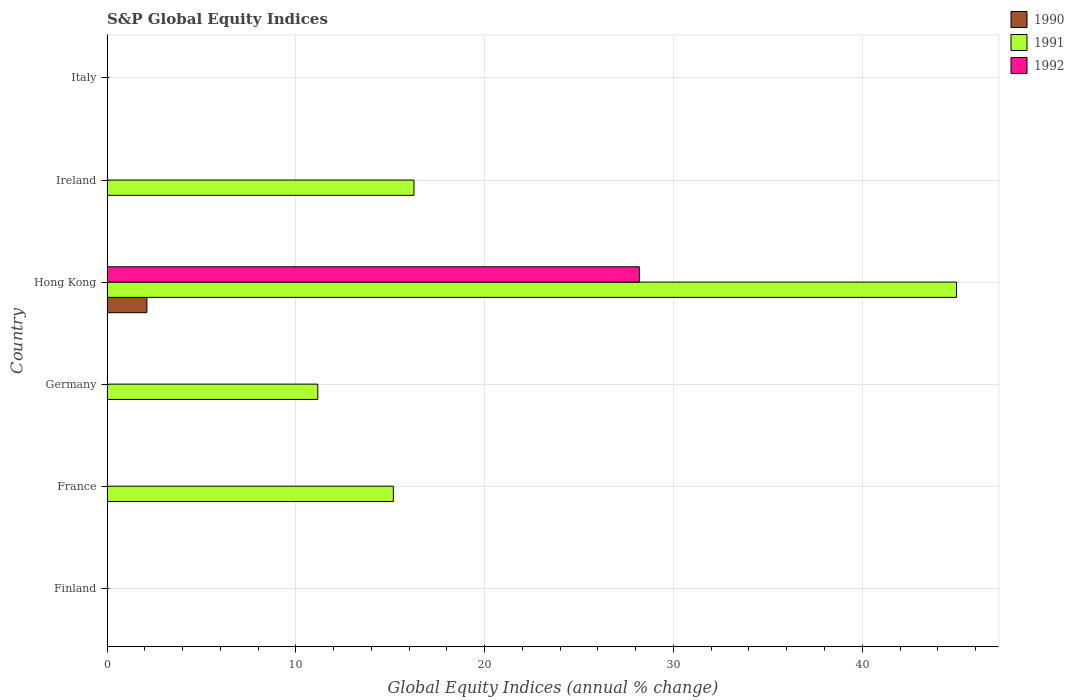Are the number of bars on each tick of the Y-axis equal?
Provide a succinct answer. No. In how many cases, is the number of bars for a given country not equal to the number of legend labels?
Make the answer very short. 5. What is the global equity indices in 1991 in Finland?
Keep it short and to the point. 0. Across all countries, what is the maximum global equity indices in 1990?
Your response must be concise. 2.11. In which country was the global equity indices in 1990 maximum?
Provide a succinct answer. Hong Kong. What is the total global equity indices in 1991 in the graph?
Make the answer very short. 87.58. What is the difference between the global equity indices in 1991 in France and that in Hong Kong?
Your answer should be compact. -29.83. What is the difference between the global equity indices in 1992 in Hong Kong and the global equity indices in 1991 in Germany?
Give a very brief answer. 17.03. What is the average global equity indices in 1990 per country?
Make the answer very short. 0.35. What is the difference between the global equity indices in 1992 and global equity indices in 1990 in Hong Kong?
Keep it short and to the point. 26.08. What is the difference between the highest and the second highest global equity indices in 1991?
Provide a short and direct response. 28.74. What is the difference between the highest and the lowest global equity indices in 1990?
Offer a very short reply. 2.11. In how many countries, is the global equity indices in 1991 greater than the average global equity indices in 1991 taken over all countries?
Offer a terse response. 3. Are all the bars in the graph horizontal?
Offer a terse response. Yes. How many countries are there in the graph?
Your answer should be very brief. 6. What is the difference between two consecutive major ticks on the X-axis?
Offer a very short reply. 10. Where does the legend appear in the graph?
Make the answer very short. Top right. How many legend labels are there?
Provide a succinct answer. 3. How are the legend labels stacked?
Your response must be concise. Vertical. What is the title of the graph?
Provide a short and direct response. S&P Global Equity Indices. What is the label or title of the X-axis?
Make the answer very short. Global Equity Indices (annual % change). What is the Global Equity Indices (annual % change) of 1992 in Finland?
Offer a very short reply. 0. What is the Global Equity Indices (annual % change) in 1990 in France?
Your answer should be very brief. 0. What is the Global Equity Indices (annual % change) of 1991 in France?
Give a very brief answer. 15.17. What is the Global Equity Indices (annual % change) of 1992 in France?
Your answer should be compact. 0. What is the Global Equity Indices (annual % change) in 1990 in Germany?
Your answer should be very brief. 0. What is the Global Equity Indices (annual % change) of 1991 in Germany?
Provide a short and direct response. 11.16. What is the Global Equity Indices (annual % change) of 1992 in Germany?
Offer a terse response. 0. What is the Global Equity Indices (annual % change) of 1990 in Hong Kong?
Your answer should be compact. 2.11. What is the Global Equity Indices (annual % change) of 1991 in Hong Kong?
Your answer should be compact. 44.99. What is the Global Equity Indices (annual % change) of 1992 in Hong Kong?
Your answer should be very brief. 28.19. What is the Global Equity Indices (annual % change) of 1990 in Ireland?
Ensure brevity in your answer.  0. What is the Global Equity Indices (annual % change) in 1991 in Ireland?
Your answer should be compact. 16.26. What is the Global Equity Indices (annual % change) in 1992 in Ireland?
Your answer should be compact. 0. What is the Global Equity Indices (annual % change) in 1991 in Italy?
Offer a very short reply. 0. What is the Global Equity Indices (annual % change) in 1992 in Italy?
Ensure brevity in your answer.  0. Across all countries, what is the maximum Global Equity Indices (annual % change) in 1990?
Give a very brief answer. 2.11. Across all countries, what is the maximum Global Equity Indices (annual % change) in 1991?
Provide a succinct answer. 44.99. Across all countries, what is the maximum Global Equity Indices (annual % change) in 1992?
Provide a succinct answer. 28.19. Across all countries, what is the minimum Global Equity Indices (annual % change) in 1990?
Ensure brevity in your answer.  0. Across all countries, what is the minimum Global Equity Indices (annual % change) of 1991?
Provide a short and direct response. 0. What is the total Global Equity Indices (annual % change) in 1990 in the graph?
Keep it short and to the point. 2.11. What is the total Global Equity Indices (annual % change) of 1991 in the graph?
Give a very brief answer. 87.58. What is the total Global Equity Indices (annual % change) in 1992 in the graph?
Offer a very short reply. 28.19. What is the difference between the Global Equity Indices (annual % change) of 1991 in France and that in Germany?
Offer a terse response. 4. What is the difference between the Global Equity Indices (annual % change) in 1991 in France and that in Hong Kong?
Keep it short and to the point. -29.83. What is the difference between the Global Equity Indices (annual % change) in 1991 in France and that in Ireland?
Give a very brief answer. -1.09. What is the difference between the Global Equity Indices (annual % change) of 1991 in Germany and that in Hong Kong?
Make the answer very short. -33.83. What is the difference between the Global Equity Indices (annual % change) of 1991 in Germany and that in Ireland?
Make the answer very short. -5.09. What is the difference between the Global Equity Indices (annual % change) in 1991 in Hong Kong and that in Ireland?
Provide a short and direct response. 28.74. What is the difference between the Global Equity Indices (annual % change) in 1991 in France and the Global Equity Indices (annual % change) in 1992 in Hong Kong?
Offer a very short reply. -13.03. What is the difference between the Global Equity Indices (annual % change) of 1991 in Germany and the Global Equity Indices (annual % change) of 1992 in Hong Kong?
Your response must be concise. -17.03. What is the difference between the Global Equity Indices (annual % change) of 1990 in Hong Kong and the Global Equity Indices (annual % change) of 1991 in Ireland?
Offer a very short reply. -14.14. What is the average Global Equity Indices (annual % change) of 1990 per country?
Make the answer very short. 0.35. What is the average Global Equity Indices (annual % change) in 1991 per country?
Ensure brevity in your answer.  14.6. What is the average Global Equity Indices (annual % change) in 1992 per country?
Give a very brief answer. 4.7. What is the difference between the Global Equity Indices (annual % change) of 1990 and Global Equity Indices (annual % change) of 1991 in Hong Kong?
Your answer should be very brief. -42.88. What is the difference between the Global Equity Indices (annual % change) of 1990 and Global Equity Indices (annual % change) of 1992 in Hong Kong?
Your answer should be very brief. -26.08. What is the difference between the Global Equity Indices (annual % change) in 1991 and Global Equity Indices (annual % change) in 1992 in Hong Kong?
Keep it short and to the point. 16.8. What is the ratio of the Global Equity Indices (annual % change) of 1991 in France to that in Germany?
Your response must be concise. 1.36. What is the ratio of the Global Equity Indices (annual % change) of 1991 in France to that in Hong Kong?
Provide a short and direct response. 0.34. What is the ratio of the Global Equity Indices (annual % change) in 1991 in France to that in Ireland?
Offer a terse response. 0.93. What is the ratio of the Global Equity Indices (annual % change) of 1991 in Germany to that in Hong Kong?
Your response must be concise. 0.25. What is the ratio of the Global Equity Indices (annual % change) in 1991 in Germany to that in Ireland?
Your answer should be very brief. 0.69. What is the ratio of the Global Equity Indices (annual % change) in 1991 in Hong Kong to that in Ireland?
Offer a very short reply. 2.77. What is the difference between the highest and the second highest Global Equity Indices (annual % change) of 1991?
Offer a very short reply. 28.74. What is the difference between the highest and the lowest Global Equity Indices (annual % change) of 1990?
Ensure brevity in your answer.  2.11. What is the difference between the highest and the lowest Global Equity Indices (annual % change) of 1991?
Your answer should be compact. 44.99. What is the difference between the highest and the lowest Global Equity Indices (annual % change) in 1992?
Provide a short and direct response. 28.19. 